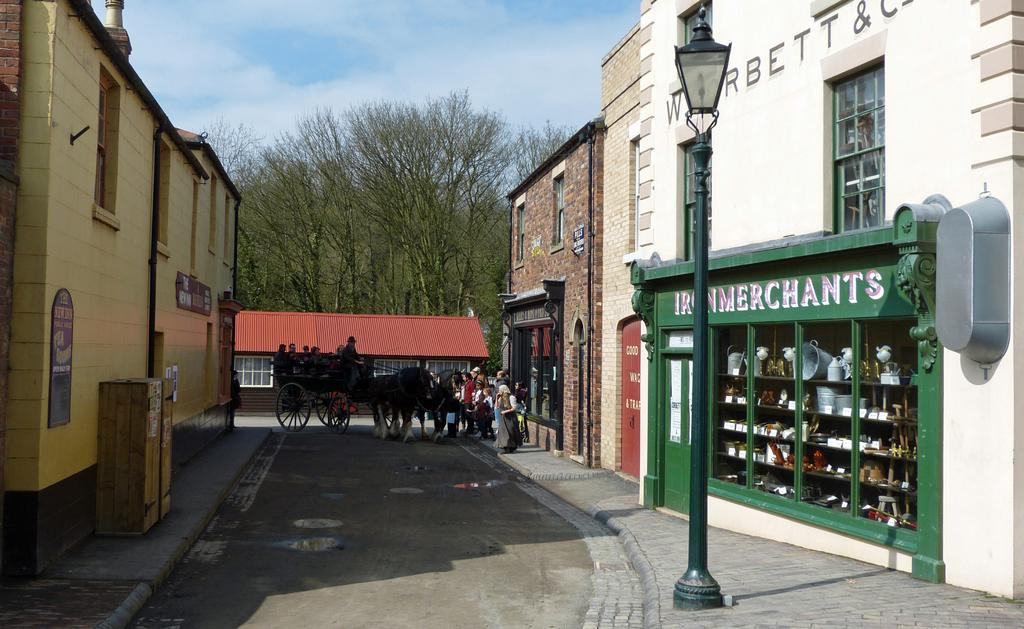<image>
Relay a brief, clear account of the picture shown. a quaint street with stores like Iron Merchants lining it 